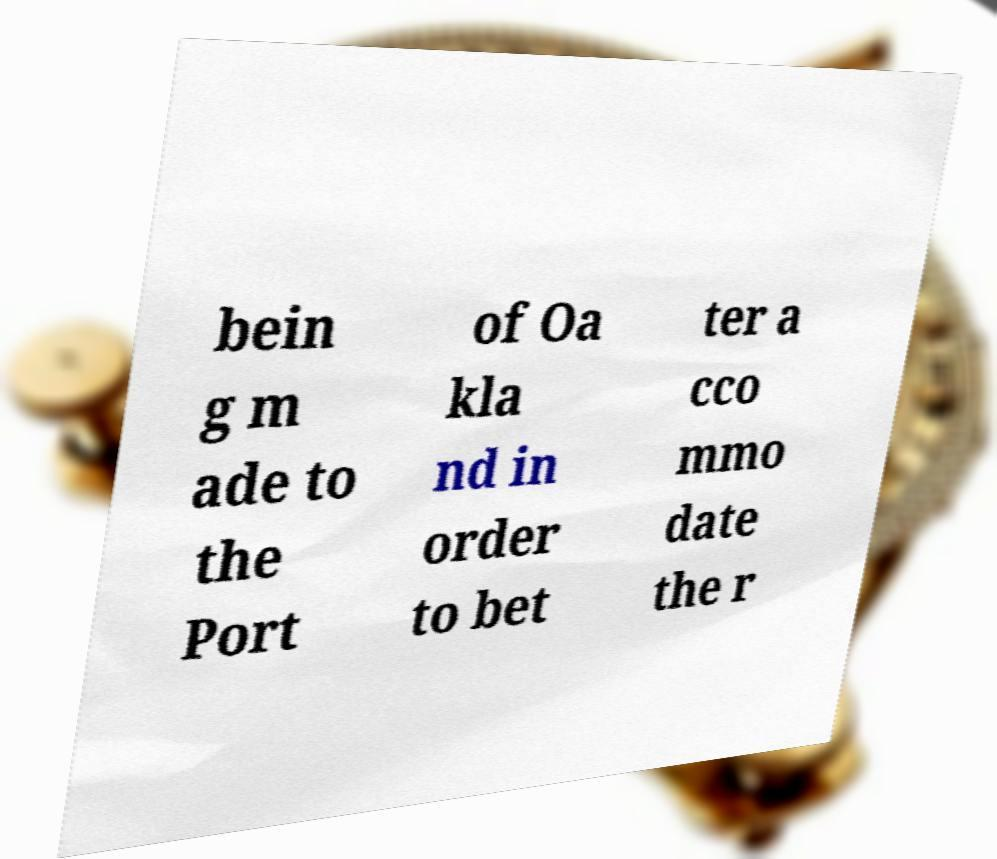Can you accurately transcribe the text from the provided image for me? bein g m ade to the Port of Oa kla nd in order to bet ter a cco mmo date the r 